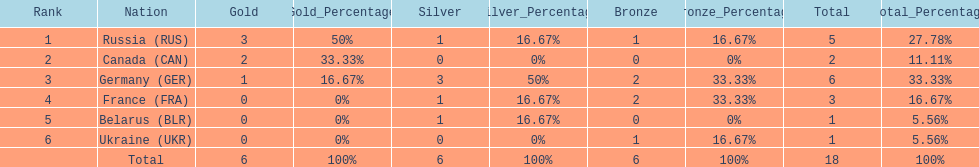How many silver medals did belarus win? 1. 